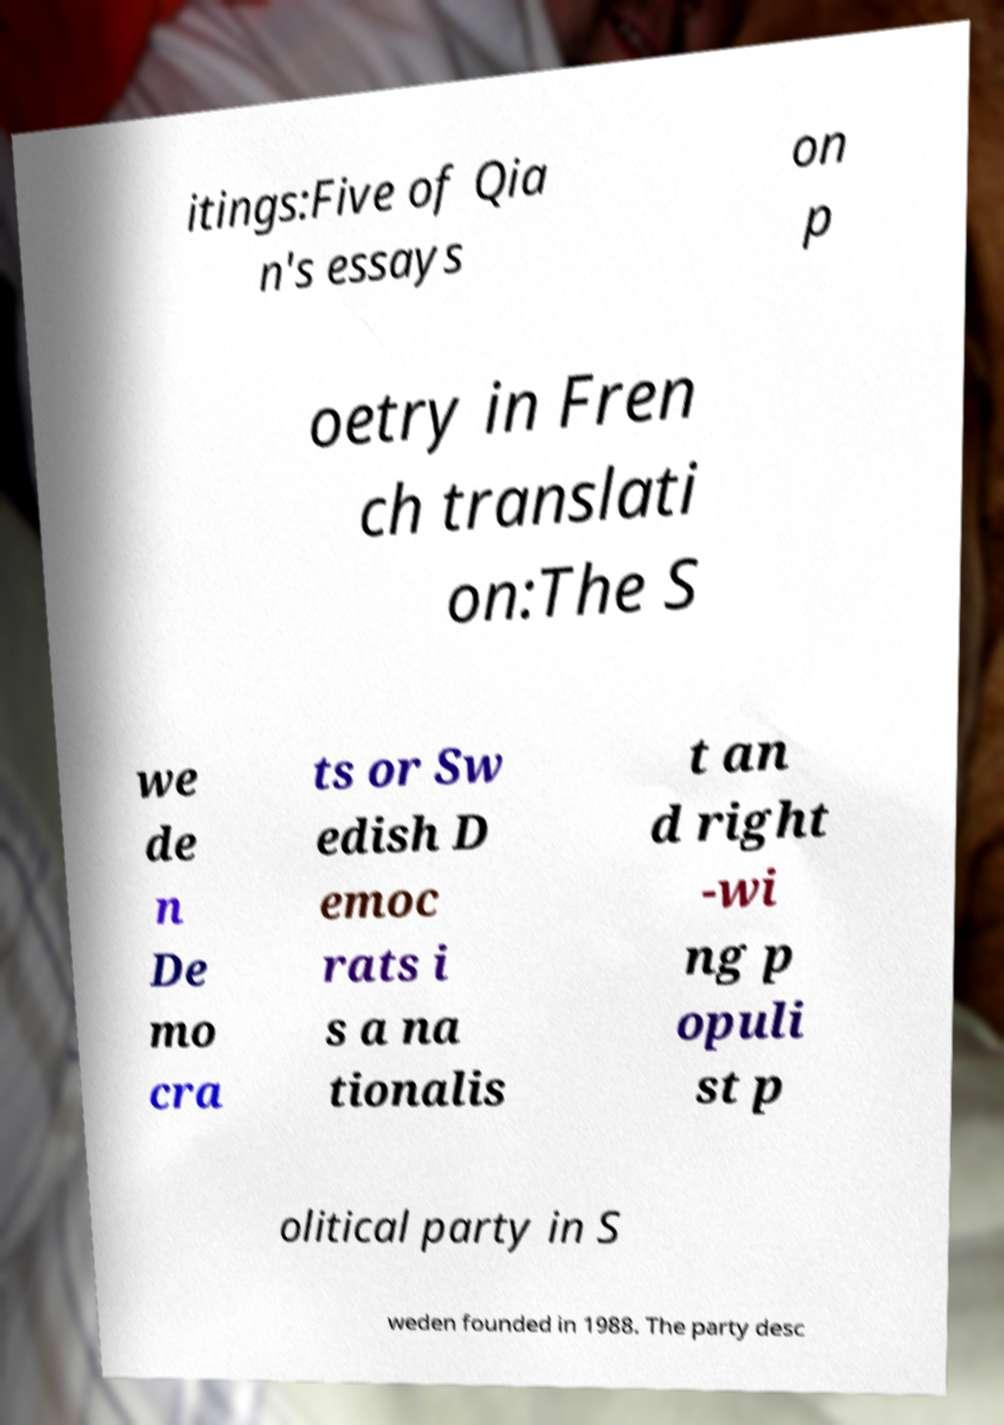Please read and relay the text visible in this image. What does it say? itings:Five of Qia n's essays on p oetry in Fren ch translati on:The S we de n De mo cra ts or Sw edish D emoc rats i s a na tionalis t an d right -wi ng p opuli st p olitical party in S weden founded in 1988. The party desc 